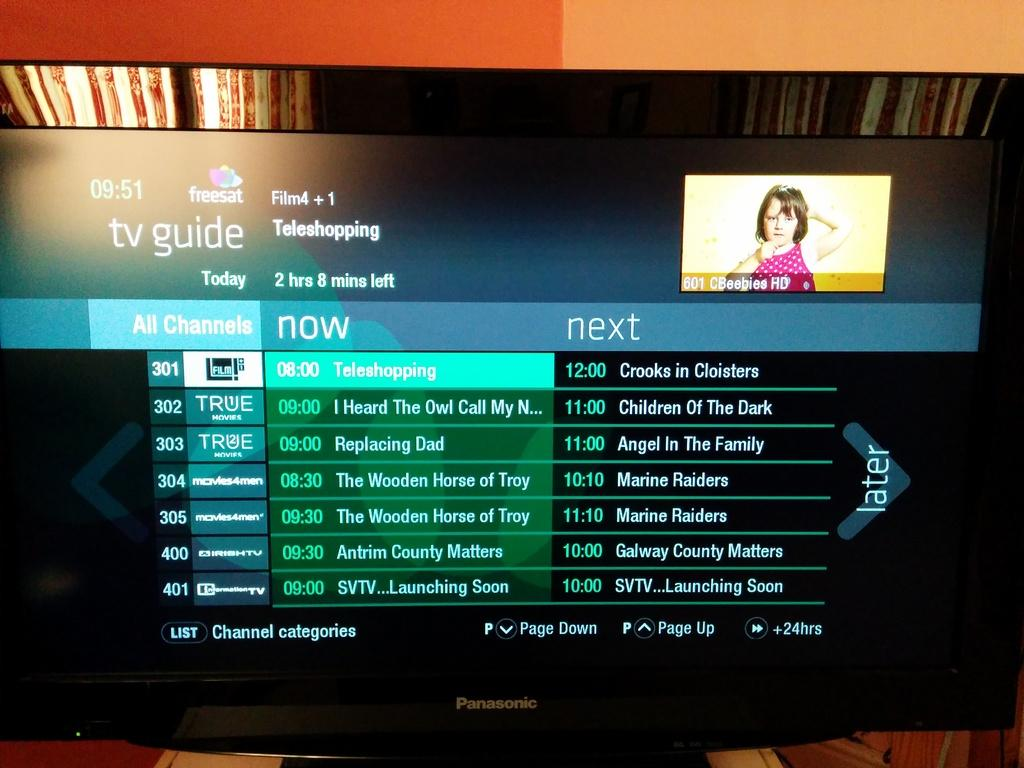<image>
Give a short and clear explanation of the subsequent image. A tv guide page that indicates there's 2 hours and 8 mins left to play. 